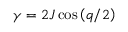<formula> <loc_0><loc_0><loc_500><loc_500>\gamma = 2 J \cos \left ( q / 2 \right )</formula> 